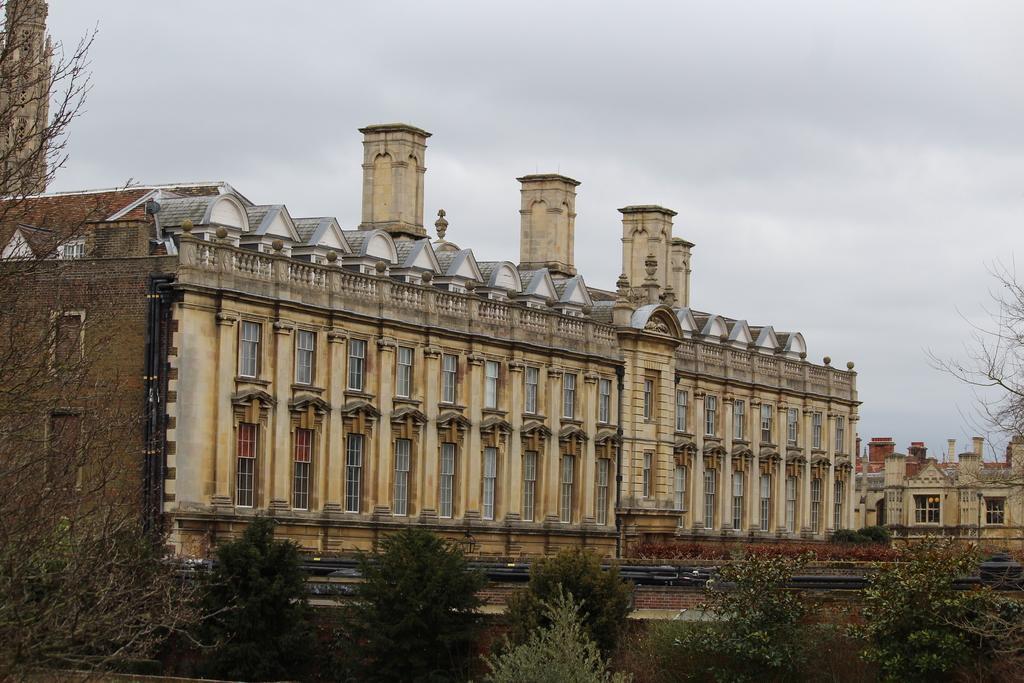In one or two sentences, can you explain what this image depicts? In this picture I can see there is a building and it has few windows and there is another building on the right side. There are few trees and the sky is cloudy. 